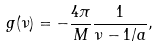<formula> <loc_0><loc_0><loc_500><loc_500>g ( \nu ) & = - \frac { 4 \pi } { M } \frac { 1 } { \nu - 1 / a } ,</formula> 